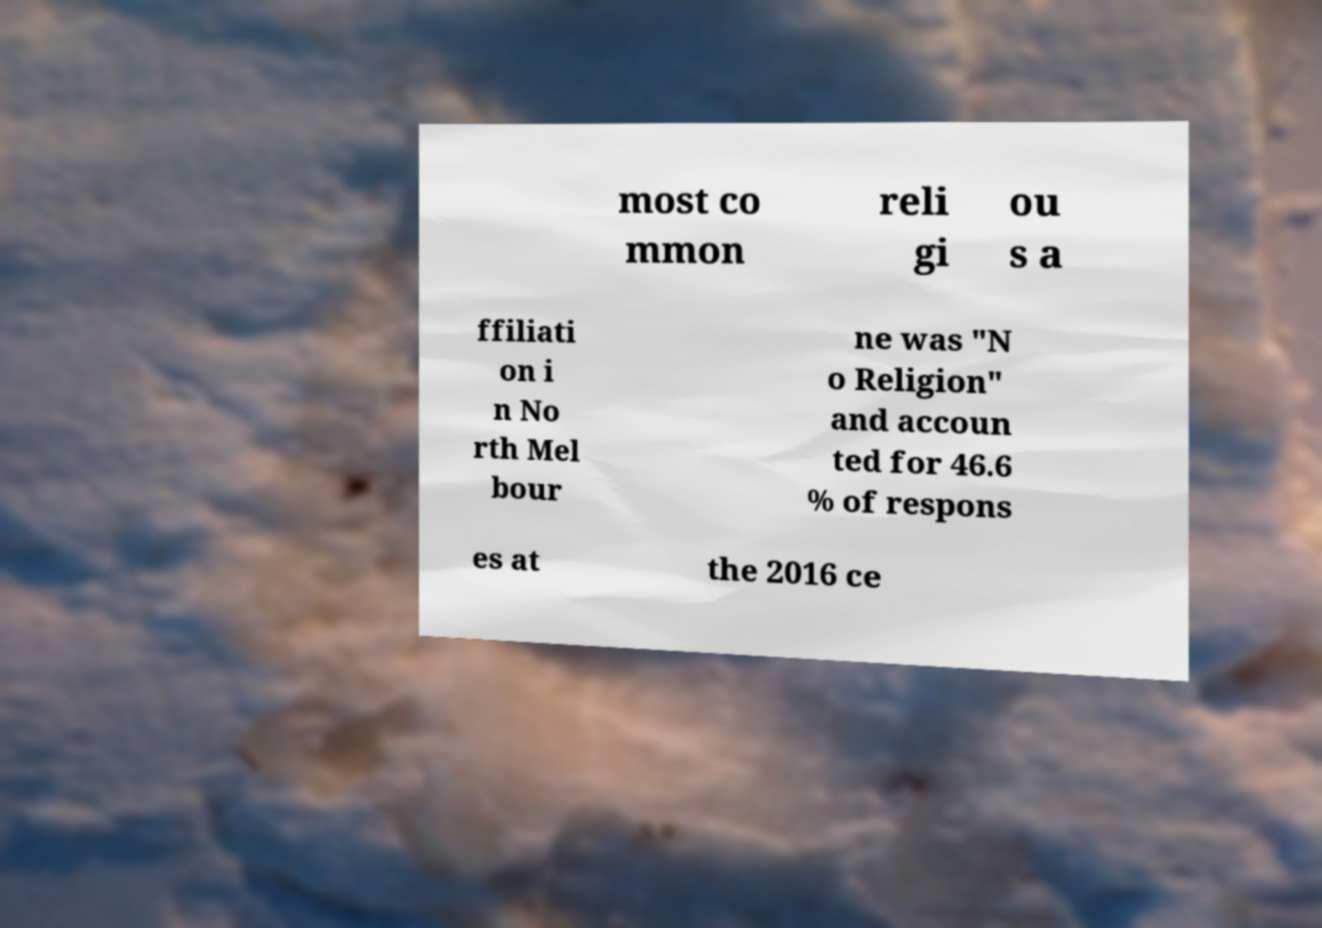Could you extract and type out the text from this image? most co mmon reli gi ou s a ffiliati on i n No rth Mel bour ne was "N o Religion" and accoun ted for 46.6 % of respons es at the 2016 ce 